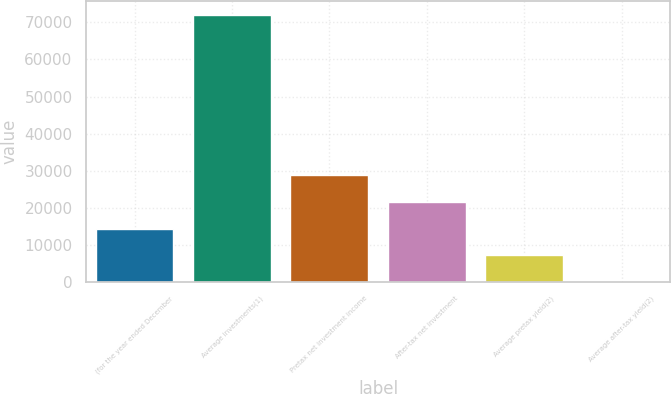Convert chart to OTSL. <chart><loc_0><loc_0><loc_500><loc_500><bar_chart><fcel>(for the year ended December<fcel>Average investments(1)<fcel>Pretax net investment income<fcel>After-tax net investment<fcel>Average pretax yield(2)<fcel>Average after-tax yield(2)<nl><fcel>14412.3<fcel>72049<fcel>28821.5<fcel>21616.9<fcel>7207.69<fcel>3.1<nl></chart> 